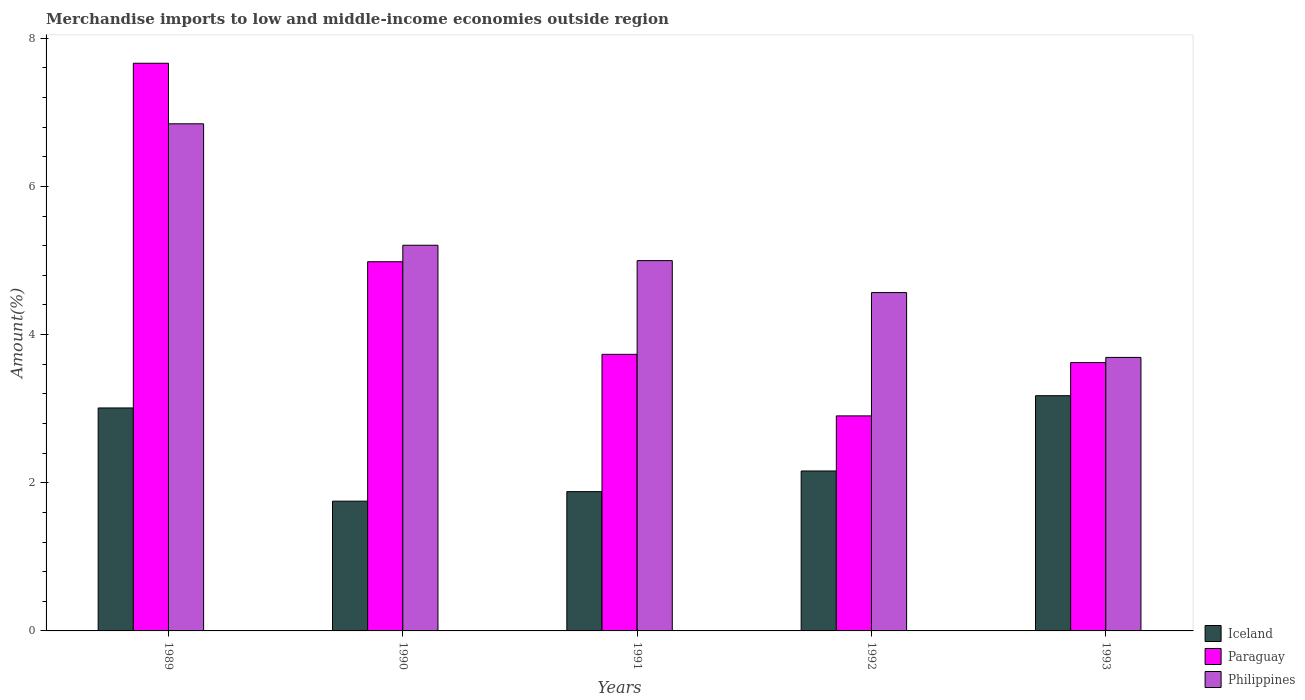How many different coloured bars are there?
Your answer should be very brief. 3. Are the number of bars per tick equal to the number of legend labels?
Provide a succinct answer. Yes. How many bars are there on the 1st tick from the right?
Ensure brevity in your answer.  3. In how many cases, is the number of bars for a given year not equal to the number of legend labels?
Provide a succinct answer. 0. What is the percentage of amount earned from merchandise imports in Paraguay in 1990?
Give a very brief answer. 4.98. Across all years, what is the maximum percentage of amount earned from merchandise imports in Philippines?
Your response must be concise. 6.85. Across all years, what is the minimum percentage of amount earned from merchandise imports in Paraguay?
Provide a short and direct response. 2.9. In which year was the percentage of amount earned from merchandise imports in Paraguay maximum?
Give a very brief answer. 1989. In which year was the percentage of amount earned from merchandise imports in Philippines minimum?
Provide a short and direct response. 1993. What is the total percentage of amount earned from merchandise imports in Iceland in the graph?
Offer a terse response. 11.98. What is the difference between the percentage of amount earned from merchandise imports in Paraguay in 1989 and that in 1991?
Make the answer very short. 3.93. What is the difference between the percentage of amount earned from merchandise imports in Paraguay in 1989 and the percentage of amount earned from merchandise imports in Philippines in 1990?
Make the answer very short. 2.46. What is the average percentage of amount earned from merchandise imports in Paraguay per year?
Give a very brief answer. 4.58. In the year 1989, what is the difference between the percentage of amount earned from merchandise imports in Paraguay and percentage of amount earned from merchandise imports in Iceland?
Keep it short and to the point. 4.65. In how many years, is the percentage of amount earned from merchandise imports in Paraguay greater than 2.4 %?
Offer a terse response. 5. What is the ratio of the percentage of amount earned from merchandise imports in Paraguay in 1989 to that in 1991?
Give a very brief answer. 2.05. Is the percentage of amount earned from merchandise imports in Iceland in 1989 less than that in 1990?
Your answer should be very brief. No. What is the difference between the highest and the second highest percentage of amount earned from merchandise imports in Philippines?
Your answer should be very brief. 1.64. What is the difference between the highest and the lowest percentage of amount earned from merchandise imports in Philippines?
Keep it short and to the point. 3.15. Is the sum of the percentage of amount earned from merchandise imports in Paraguay in 1992 and 1993 greater than the maximum percentage of amount earned from merchandise imports in Philippines across all years?
Offer a very short reply. No. What does the 1st bar from the left in 1991 represents?
Offer a very short reply. Iceland. What does the 2nd bar from the right in 1993 represents?
Offer a very short reply. Paraguay. How many years are there in the graph?
Offer a very short reply. 5. What is the difference between two consecutive major ticks on the Y-axis?
Ensure brevity in your answer.  2. Are the values on the major ticks of Y-axis written in scientific E-notation?
Provide a succinct answer. No. Does the graph contain any zero values?
Make the answer very short. No. Does the graph contain grids?
Your response must be concise. No. Where does the legend appear in the graph?
Provide a short and direct response. Bottom right. How are the legend labels stacked?
Offer a very short reply. Vertical. What is the title of the graph?
Make the answer very short. Merchandise imports to low and middle-income economies outside region. Does "East Asia (all income levels)" appear as one of the legend labels in the graph?
Provide a short and direct response. No. What is the label or title of the Y-axis?
Offer a very short reply. Amount(%). What is the Amount(%) of Iceland in 1989?
Provide a short and direct response. 3.01. What is the Amount(%) in Paraguay in 1989?
Your answer should be very brief. 7.66. What is the Amount(%) in Philippines in 1989?
Your response must be concise. 6.85. What is the Amount(%) in Iceland in 1990?
Give a very brief answer. 1.75. What is the Amount(%) in Paraguay in 1990?
Offer a terse response. 4.98. What is the Amount(%) of Philippines in 1990?
Offer a terse response. 5.21. What is the Amount(%) of Iceland in 1991?
Keep it short and to the point. 1.88. What is the Amount(%) of Paraguay in 1991?
Provide a short and direct response. 3.73. What is the Amount(%) of Philippines in 1991?
Offer a terse response. 5. What is the Amount(%) in Iceland in 1992?
Provide a succinct answer. 2.16. What is the Amount(%) in Paraguay in 1992?
Your answer should be compact. 2.9. What is the Amount(%) in Philippines in 1992?
Offer a terse response. 4.57. What is the Amount(%) of Iceland in 1993?
Your answer should be very brief. 3.18. What is the Amount(%) in Paraguay in 1993?
Provide a succinct answer. 3.62. What is the Amount(%) in Philippines in 1993?
Provide a short and direct response. 3.69. Across all years, what is the maximum Amount(%) in Iceland?
Provide a succinct answer. 3.18. Across all years, what is the maximum Amount(%) in Paraguay?
Offer a very short reply. 7.66. Across all years, what is the maximum Amount(%) in Philippines?
Offer a very short reply. 6.85. Across all years, what is the minimum Amount(%) in Iceland?
Ensure brevity in your answer.  1.75. Across all years, what is the minimum Amount(%) of Paraguay?
Give a very brief answer. 2.9. Across all years, what is the minimum Amount(%) in Philippines?
Provide a succinct answer. 3.69. What is the total Amount(%) of Iceland in the graph?
Provide a succinct answer. 11.98. What is the total Amount(%) of Paraguay in the graph?
Provide a short and direct response. 22.9. What is the total Amount(%) of Philippines in the graph?
Your answer should be very brief. 25.31. What is the difference between the Amount(%) of Iceland in 1989 and that in 1990?
Offer a terse response. 1.26. What is the difference between the Amount(%) in Paraguay in 1989 and that in 1990?
Provide a short and direct response. 2.68. What is the difference between the Amount(%) of Philippines in 1989 and that in 1990?
Your response must be concise. 1.64. What is the difference between the Amount(%) of Iceland in 1989 and that in 1991?
Make the answer very short. 1.13. What is the difference between the Amount(%) of Paraguay in 1989 and that in 1991?
Your response must be concise. 3.93. What is the difference between the Amount(%) in Philippines in 1989 and that in 1991?
Make the answer very short. 1.85. What is the difference between the Amount(%) in Iceland in 1989 and that in 1992?
Ensure brevity in your answer.  0.85. What is the difference between the Amount(%) in Paraguay in 1989 and that in 1992?
Ensure brevity in your answer.  4.76. What is the difference between the Amount(%) in Philippines in 1989 and that in 1992?
Your answer should be very brief. 2.28. What is the difference between the Amount(%) of Iceland in 1989 and that in 1993?
Keep it short and to the point. -0.17. What is the difference between the Amount(%) of Paraguay in 1989 and that in 1993?
Offer a terse response. 4.04. What is the difference between the Amount(%) of Philippines in 1989 and that in 1993?
Provide a short and direct response. 3.15. What is the difference between the Amount(%) in Iceland in 1990 and that in 1991?
Your response must be concise. -0.13. What is the difference between the Amount(%) in Paraguay in 1990 and that in 1991?
Give a very brief answer. 1.25. What is the difference between the Amount(%) in Philippines in 1990 and that in 1991?
Give a very brief answer. 0.21. What is the difference between the Amount(%) of Iceland in 1990 and that in 1992?
Ensure brevity in your answer.  -0.41. What is the difference between the Amount(%) in Paraguay in 1990 and that in 1992?
Offer a terse response. 2.08. What is the difference between the Amount(%) of Philippines in 1990 and that in 1992?
Your response must be concise. 0.64. What is the difference between the Amount(%) of Iceland in 1990 and that in 1993?
Provide a short and direct response. -1.42. What is the difference between the Amount(%) of Paraguay in 1990 and that in 1993?
Keep it short and to the point. 1.36. What is the difference between the Amount(%) in Philippines in 1990 and that in 1993?
Give a very brief answer. 1.51. What is the difference between the Amount(%) in Iceland in 1991 and that in 1992?
Your answer should be compact. -0.28. What is the difference between the Amount(%) in Paraguay in 1991 and that in 1992?
Offer a very short reply. 0.83. What is the difference between the Amount(%) of Philippines in 1991 and that in 1992?
Your answer should be very brief. 0.43. What is the difference between the Amount(%) of Iceland in 1991 and that in 1993?
Give a very brief answer. -1.29. What is the difference between the Amount(%) in Paraguay in 1991 and that in 1993?
Provide a short and direct response. 0.11. What is the difference between the Amount(%) in Philippines in 1991 and that in 1993?
Your answer should be compact. 1.31. What is the difference between the Amount(%) of Iceland in 1992 and that in 1993?
Make the answer very short. -1.02. What is the difference between the Amount(%) in Paraguay in 1992 and that in 1993?
Offer a terse response. -0.72. What is the difference between the Amount(%) in Philippines in 1992 and that in 1993?
Give a very brief answer. 0.88. What is the difference between the Amount(%) of Iceland in 1989 and the Amount(%) of Paraguay in 1990?
Give a very brief answer. -1.97. What is the difference between the Amount(%) of Iceland in 1989 and the Amount(%) of Philippines in 1990?
Offer a terse response. -2.2. What is the difference between the Amount(%) in Paraguay in 1989 and the Amount(%) in Philippines in 1990?
Keep it short and to the point. 2.46. What is the difference between the Amount(%) in Iceland in 1989 and the Amount(%) in Paraguay in 1991?
Provide a succinct answer. -0.72. What is the difference between the Amount(%) of Iceland in 1989 and the Amount(%) of Philippines in 1991?
Give a very brief answer. -1.99. What is the difference between the Amount(%) in Paraguay in 1989 and the Amount(%) in Philippines in 1991?
Your answer should be compact. 2.66. What is the difference between the Amount(%) of Iceland in 1989 and the Amount(%) of Paraguay in 1992?
Ensure brevity in your answer.  0.11. What is the difference between the Amount(%) of Iceland in 1989 and the Amount(%) of Philippines in 1992?
Keep it short and to the point. -1.56. What is the difference between the Amount(%) of Paraguay in 1989 and the Amount(%) of Philippines in 1992?
Your answer should be very brief. 3.1. What is the difference between the Amount(%) of Iceland in 1989 and the Amount(%) of Paraguay in 1993?
Ensure brevity in your answer.  -0.61. What is the difference between the Amount(%) of Iceland in 1989 and the Amount(%) of Philippines in 1993?
Provide a succinct answer. -0.68. What is the difference between the Amount(%) of Paraguay in 1989 and the Amount(%) of Philippines in 1993?
Offer a terse response. 3.97. What is the difference between the Amount(%) in Iceland in 1990 and the Amount(%) in Paraguay in 1991?
Your answer should be very brief. -1.98. What is the difference between the Amount(%) in Iceland in 1990 and the Amount(%) in Philippines in 1991?
Offer a terse response. -3.25. What is the difference between the Amount(%) of Paraguay in 1990 and the Amount(%) of Philippines in 1991?
Give a very brief answer. -0.01. What is the difference between the Amount(%) of Iceland in 1990 and the Amount(%) of Paraguay in 1992?
Provide a succinct answer. -1.15. What is the difference between the Amount(%) of Iceland in 1990 and the Amount(%) of Philippines in 1992?
Your answer should be compact. -2.82. What is the difference between the Amount(%) of Paraguay in 1990 and the Amount(%) of Philippines in 1992?
Offer a terse response. 0.42. What is the difference between the Amount(%) of Iceland in 1990 and the Amount(%) of Paraguay in 1993?
Your answer should be compact. -1.87. What is the difference between the Amount(%) in Iceland in 1990 and the Amount(%) in Philippines in 1993?
Offer a very short reply. -1.94. What is the difference between the Amount(%) of Paraguay in 1990 and the Amount(%) of Philippines in 1993?
Offer a very short reply. 1.29. What is the difference between the Amount(%) in Iceland in 1991 and the Amount(%) in Paraguay in 1992?
Offer a terse response. -1.02. What is the difference between the Amount(%) in Iceland in 1991 and the Amount(%) in Philippines in 1992?
Your answer should be very brief. -2.69. What is the difference between the Amount(%) in Paraguay in 1991 and the Amount(%) in Philippines in 1992?
Provide a short and direct response. -0.83. What is the difference between the Amount(%) in Iceland in 1991 and the Amount(%) in Paraguay in 1993?
Your response must be concise. -1.74. What is the difference between the Amount(%) of Iceland in 1991 and the Amount(%) of Philippines in 1993?
Keep it short and to the point. -1.81. What is the difference between the Amount(%) of Paraguay in 1991 and the Amount(%) of Philippines in 1993?
Offer a terse response. 0.04. What is the difference between the Amount(%) of Iceland in 1992 and the Amount(%) of Paraguay in 1993?
Provide a succinct answer. -1.46. What is the difference between the Amount(%) in Iceland in 1992 and the Amount(%) in Philippines in 1993?
Your answer should be very brief. -1.53. What is the difference between the Amount(%) of Paraguay in 1992 and the Amount(%) of Philippines in 1993?
Your response must be concise. -0.79. What is the average Amount(%) in Iceland per year?
Your answer should be very brief. 2.4. What is the average Amount(%) of Paraguay per year?
Make the answer very short. 4.58. What is the average Amount(%) in Philippines per year?
Your response must be concise. 5.06. In the year 1989, what is the difference between the Amount(%) in Iceland and Amount(%) in Paraguay?
Ensure brevity in your answer.  -4.65. In the year 1989, what is the difference between the Amount(%) of Iceland and Amount(%) of Philippines?
Provide a short and direct response. -3.84. In the year 1989, what is the difference between the Amount(%) in Paraguay and Amount(%) in Philippines?
Provide a short and direct response. 0.82. In the year 1990, what is the difference between the Amount(%) in Iceland and Amount(%) in Paraguay?
Keep it short and to the point. -3.23. In the year 1990, what is the difference between the Amount(%) in Iceland and Amount(%) in Philippines?
Your response must be concise. -3.45. In the year 1990, what is the difference between the Amount(%) in Paraguay and Amount(%) in Philippines?
Provide a succinct answer. -0.22. In the year 1991, what is the difference between the Amount(%) of Iceland and Amount(%) of Paraguay?
Your response must be concise. -1.85. In the year 1991, what is the difference between the Amount(%) in Iceland and Amount(%) in Philippines?
Keep it short and to the point. -3.12. In the year 1991, what is the difference between the Amount(%) in Paraguay and Amount(%) in Philippines?
Provide a succinct answer. -1.27. In the year 1992, what is the difference between the Amount(%) of Iceland and Amount(%) of Paraguay?
Ensure brevity in your answer.  -0.74. In the year 1992, what is the difference between the Amount(%) in Iceland and Amount(%) in Philippines?
Make the answer very short. -2.41. In the year 1992, what is the difference between the Amount(%) of Paraguay and Amount(%) of Philippines?
Provide a succinct answer. -1.66. In the year 1993, what is the difference between the Amount(%) in Iceland and Amount(%) in Paraguay?
Offer a very short reply. -0.45. In the year 1993, what is the difference between the Amount(%) of Iceland and Amount(%) of Philippines?
Your answer should be compact. -0.52. In the year 1993, what is the difference between the Amount(%) of Paraguay and Amount(%) of Philippines?
Ensure brevity in your answer.  -0.07. What is the ratio of the Amount(%) of Iceland in 1989 to that in 1990?
Your response must be concise. 1.72. What is the ratio of the Amount(%) of Paraguay in 1989 to that in 1990?
Keep it short and to the point. 1.54. What is the ratio of the Amount(%) in Philippines in 1989 to that in 1990?
Make the answer very short. 1.31. What is the ratio of the Amount(%) of Iceland in 1989 to that in 1991?
Make the answer very short. 1.6. What is the ratio of the Amount(%) of Paraguay in 1989 to that in 1991?
Give a very brief answer. 2.05. What is the ratio of the Amount(%) in Philippines in 1989 to that in 1991?
Make the answer very short. 1.37. What is the ratio of the Amount(%) in Iceland in 1989 to that in 1992?
Provide a succinct answer. 1.39. What is the ratio of the Amount(%) of Paraguay in 1989 to that in 1992?
Make the answer very short. 2.64. What is the ratio of the Amount(%) in Philippines in 1989 to that in 1992?
Ensure brevity in your answer.  1.5. What is the ratio of the Amount(%) of Iceland in 1989 to that in 1993?
Offer a terse response. 0.95. What is the ratio of the Amount(%) of Paraguay in 1989 to that in 1993?
Provide a short and direct response. 2.12. What is the ratio of the Amount(%) of Philippines in 1989 to that in 1993?
Offer a very short reply. 1.85. What is the ratio of the Amount(%) of Iceland in 1990 to that in 1991?
Offer a terse response. 0.93. What is the ratio of the Amount(%) of Paraguay in 1990 to that in 1991?
Give a very brief answer. 1.33. What is the ratio of the Amount(%) in Philippines in 1990 to that in 1991?
Keep it short and to the point. 1.04. What is the ratio of the Amount(%) in Iceland in 1990 to that in 1992?
Give a very brief answer. 0.81. What is the ratio of the Amount(%) in Paraguay in 1990 to that in 1992?
Offer a terse response. 1.72. What is the ratio of the Amount(%) in Philippines in 1990 to that in 1992?
Your answer should be very brief. 1.14. What is the ratio of the Amount(%) in Iceland in 1990 to that in 1993?
Your answer should be very brief. 0.55. What is the ratio of the Amount(%) of Paraguay in 1990 to that in 1993?
Provide a short and direct response. 1.38. What is the ratio of the Amount(%) in Philippines in 1990 to that in 1993?
Your answer should be compact. 1.41. What is the ratio of the Amount(%) in Iceland in 1991 to that in 1992?
Your answer should be very brief. 0.87. What is the ratio of the Amount(%) in Paraguay in 1991 to that in 1992?
Your response must be concise. 1.29. What is the ratio of the Amount(%) in Philippines in 1991 to that in 1992?
Your answer should be compact. 1.09. What is the ratio of the Amount(%) of Iceland in 1991 to that in 1993?
Ensure brevity in your answer.  0.59. What is the ratio of the Amount(%) of Paraguay in 1991 to that in 1993?
Offer a terse response. 1.03. What is the ratio of the Amount(%) in Philippines in 1991 to that in 1993?
Make the answer very short. 1.35. What is the ratio of the Amount(%) of Iceland in 1992 to that in 1993?
Provide a succinct answer. 0.68. What is the ratio of the Amount(%) of Paraguay in 1992 to that in 1993?
Your response must be concise. 0.8. What is the ratio of the Amount(%) of Philippines in 1992 to that in 1993?
Your response must be concise. 1.24. What is the difference between the highest and the second highest Amount(%) of Iceland?
Give a very brief answer. 0.17. What is the difference between the highest and the second highest Amount(%) in Paraguay?
Your answer should be compact. 2.68. What is the difference between the highest and the second highest Amount(%) of Philippines?
Provide a succinct answer. 1.64. What is the difference between the highest and the lowest Amount(%) of Iceland?
Your answer should be compact. 1.42. What is the difference between the highest and the lowest Amount(%) in Paraguay?
Offer a very short reply. 4.76. What is the difference between the highest and the lowest Amount(%) of Philippines?
Offer a very short reply. 3.15. 